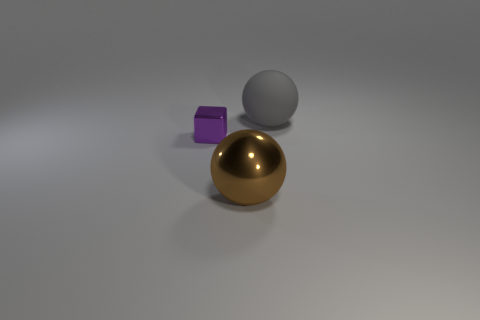Are there any other things that have the same material as the gray sphere?
Your answer should be compact. No. Are there the same number of big things behind the large gray matte thing and tiny metallic cubes that are to the left of the block?
Offer a very short reply. Yes. There is a big rubber object that is the same shape as the big shiny object; what is its color?
Your answer should be compact. Gray. Is there anything else that is the same color as the matte object?
Provide a succinct answer. No. What number of rubber things are brown objects or gray spheres?
Make the answer very short. 1. Is the number of balls right of the large brown shiny object greater than the number of purple metallic spheres?
Make the answer very short. Yes. What number of other things are the same material as the large gray thing?
Offer a very short reply. 0. What number of tiny objects are purple metallic blocks or metal objects?
Keep it short and to the point. 1. Do the small purple thing and the big gray sphere have the same material?
Your answer should be very brief. No. What number of big matte objects are to the right of the large ball that is in front of the purple object?
Offer a very short reply. 1. 